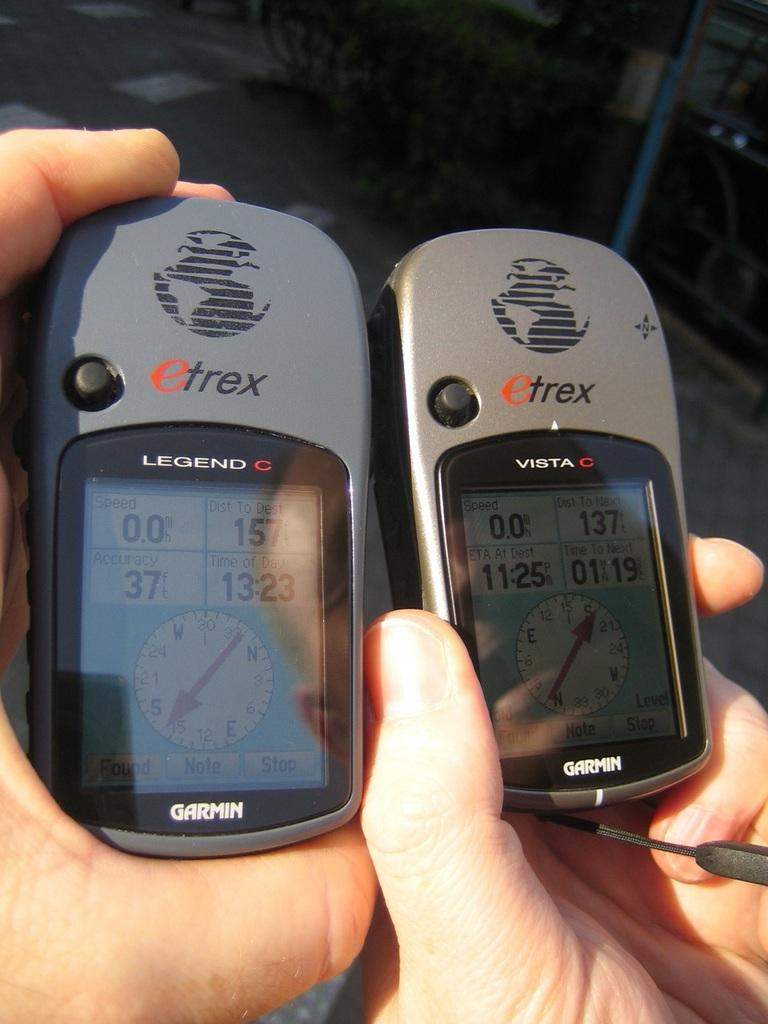Provide a one-sentence caption for the provided image. Garmin Etrex Legend and Vista C device that tracks distance and direction. 